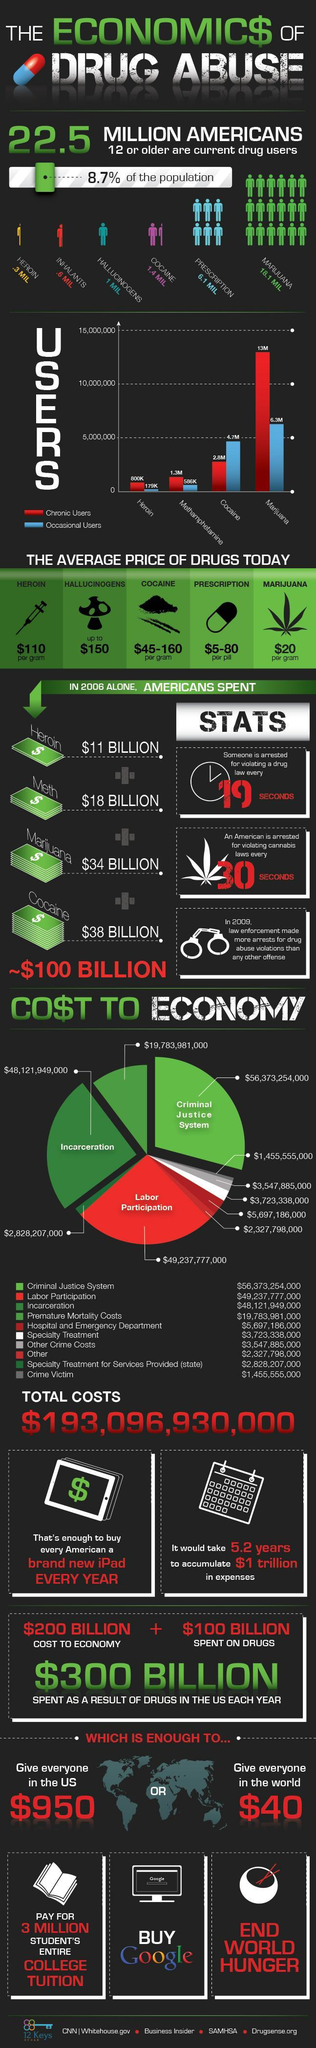How many people are chronic users of Cocaine?
Answer the question with a short phrase. 2.8M What is the difference in number of chronic and occasional users of Heroin? 621K How many people use marijuana occasionally? 6.3M Among heroin, cocaine and marijuana, which drug is expensive? Cocaine 